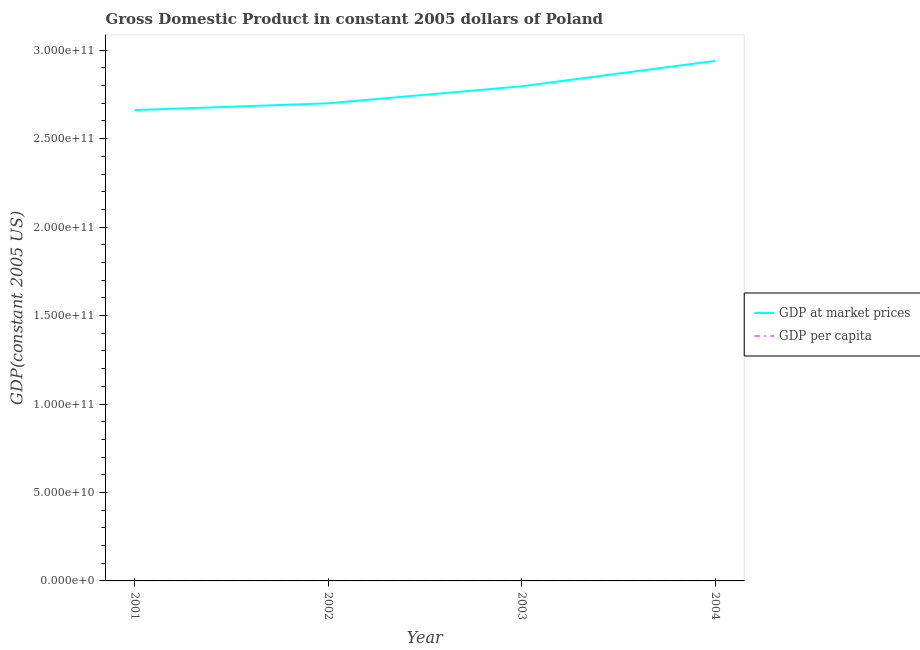Is the number of lines equal to the number of legend labels?
Your answer should be very brief. Yes. What is the gdp at market prices in 2002?
Your answer should be very brief. 2.70e+11. Across all years, what is the maximum gdp at market prices?
Provide a succinct answer. 2.94e+11. Across all years, what is the minimum gdp per capita?
Offer a terse response. 6958.81. In which year was the gdp at market prices maximum?
Your response must be concise. 2004. What is the total gdp at market prices in the graph?
Offer a very short reply. 1.11e+12. What is the difference between the gdp at market prices in 2003 and that in 2004?
Provide a short and direct response. -1.44e+1. What is the difference between the gdp at market prices in 2004 and the gdp per capita in 2002?
Give a very brief answer. 2.94e+11. What is the average gdp per capita per year?
Your answer should be very brief. 7259.97. In the year 2001, what is the difference between the gdp at market prices and gdp per capita?
Your answer should be compact. 2.66e+11. What is the ratio of the gdp per capita in 2001 to that in 2002?
Ensure brevity in your answer.  0.99. Is the gdp per capita in 2001 less than that in 2004?
Your answer should be compact. Yes. What is the difference between the highest and the second highest gdp per capita?
Ensure brevity in your answer.  380.39. What is the difference between the highest and the lowest gdp per capita?
Provide a succinct answer. 740.65. In how many years, is the gdp at market prices greater than the average gdp at market prices taken over all years?
Ensure brevity in your answer.  2. Is the sum of the gdp per capita in 2001 and 2002 greater than the maximum gdp at market prices across all years?
Offer a very short reply. No. Is the gdp per capita strictly less than the gdp at market prices over the years?
Your answer should be very brief. Yes. How many years are there in the graph?
Your response must be concise. 4. Does the graph contain grids?
Your response must be concise. No. Where does the legend appear in the graph?
Your answer should be very brief. Center right. How many legend labels are there?
Give a very brief answer. 2. How are the legend labels stacked?
Make the answer very short. Vertical. What is the title of the graph?
Give a very brief answer. Gross Domestic Product in constant 2005 dollars of Poland. Does "Private creditors" appear as one of the legend labels in the graph?
Your answer should be compact. No. What is the label or title of the Y-axis?
Your answer should be very brief. GDP(constant 2005 US). What is the GDP(constant 2005 US) of GDP at market prices in 2001?
Provide a short and direct response. 2.66e+11. What is the GDP(constant 2005 US) of GDP per capita in 2001?
Provide a short and direct response. 6958.81. What is the GDP(constant 2005 US) of GDP at market prices in 2002?
Ensure brevity in your answer.  2.70e+11. What is the GDP(constant 2005 US) in GDP per capita in 2002?
Give a very brief answer. 7062.53. What is the GDP(constant 2005 US) in GDP at market prices in 2003?
Your response must be concise. 2.80e+11. What is the GDP(constant 2005 US) in GDP per capita in 2003?
Your answer should be very brief. 7319.07. What is the GDP(constant 2005 US) in GDP at market prices in 2004?
Keep it short and to the point. 2.94e+11. What is the GDP(constant 2005 US) in GDP per capita in 2004?
Offer a very short reply. 7699.46. Across all years, what is the maximum GDP(constant 2005 US) of GDP at market prices?
Provide a short and direct response. 2.94e+11. Across all years, what is the maximum GDP(constant 2005 US) of GDP per capita?
Your answer should be compact. 7699.46. Across all years, what is the minimum GDP(constant 2005 US) of GDP at market prices?
Keep it short and to the point. 2.66e+11. Across all years, what is the minimum GDP(constant 2005 US) of GDP per capita?
Your response must be concise. 6958.81. What is the total GDP(constant 2005 US) in GDP at market prices in the graph?
Offer a terse response. 1.11e+12. What is the total GDP(constant 2005 US) of GDP per capita in the graph?
Your answer should be very brief. 2.90e+04. What is the difference between the GDP(constant 2005 US) in GDP at market prices in 2001 and that in 2002?
Your response must be concise. -3.84e+09. What is the difference between the GDP(constant 2005 US) of GDP per capita in 2001 and that in 2002?
Provide a short and direct response. -103.72. What is the difference between the GDP(constant 2005 US) of GDP at market prices in 2001 and that in 2003?
Give a very brief answer. -1.35e+1. What is the difference between the GDP(constant 2005 US) of GDP per capita in 2001 and that in 2003?
Your answer should be very brief. -360.26. What is the difference between the GDP(constant 2005 US) of GDP at market prices in 2001 and that in 2004?
Offer a terse response. -2.78e+1. What is the difference between the GDP(constant 2005 US) in GDP per capita in 2001 and that in 2004?
Your answer should be compact. -740.65. What is the difference between the GDP(constant 2005 US) in GDP at market prices in 2002 and that in 2003?
Provide a succinct answer. -9.62e+09. What is the difference between the GDP(constant 2005 US) in GDP per capita in 2002 and that in 2003?
Your answer should be very brief. -256.54. What is the difference between the GDP(constant 2005 US) of GDP at market prices in 2002 and that in 2004?
Give a very brief answer. -2.40e+1. What is the difference between the GDP(constant 2005 US) in GDP per capita in 2002 and that in 2004?
Keep it short and to the point. -636.93. What is the difference between the GDP(constant 2005 US) of GDP at market prices in 2003 and that in 2004?
Offer a very short reply. -1.44e+1. What is the difference between the GDP(constant 2005 US) in GDP per capita in 2003 and that in 2004?
Offer a very short reply. -380.39. What is the difference between the GDP(constant 2005 US) of GDP at market prices in 2001 and the GDP(constant 2005 US) of GDP per capita in 2002?
Offer a terse response. 2.66e+11. What is the difference between the GDP(constant 2005 US) in GDP at market prices in 2001 and the GDP(constant 2005 US) in GDP per capita in 2003?
Provide a succinct answer. 2.66e+11. What is the difference between the GDP(constant 2005 US) of GDP at market prices in 2001 and the GDP(constant 2005 US) of GDP per capita in 2004?
Your response must be concise. 2.66e+11. What is the difference between the GDP(constant 2005 US) of GDP at market prices in 2002 and the GDP(constant 2005 US) of GDP per capita in 2003?
Offer a terse response. 2.70e+11. What is the difference between the GDP(constant 2005 US) in GDP at market prices in 2002 and the GDP(constant 2005 US) in GDP per capita in 2004?
Provide a succinct answer. 2.70e+11. What is the difference between the GDP(constant 2005 US) in GDP at market prices in 2003 and the GDP(constant 2005 US) in GDP per capita in 2004?
Your response must be concise. 2.80e+11. What is the average GDP(constant 2005 US) of GDP at market prices per year?
Make the answer very short. 2.77e+11. What is the average GDP(constant 2005 US) of GDP per capita per year?
Give a very brief answer. 7259.97. In the year 2001, what is the difference between the GDP(constant 2005 US) of GDP at market prices and GDP(constant 2005 US) of GDP per capita?
Keep it short and to the point. 2.66e+11. In the year 2002, what is the difference between the GDP(constant 2005 US) of GDP at market prices and GDP(constant 2005 US) of GDP per capita?
Ensure brevity in your answer.  2.70e+11. In the year 2003, what is the difference between the GDP(constant 2005 US) of GDP at market prices and GDP(constant 2005 US) of GDP per capita?
Give a very brief answer. 2.80e+11. In the year 2004, what is the difference between the GDP(constant 2005 US) of GDP at market prices and GDP(constant 2005 US) of GDP per capita?
Make the answer very short. 2.94e+11. What is the ratio of the GDP(constant 2005 US) of GDP at market prices in 2001 to that in 2002?
Offer a terse response. 0.99. What is the ratio of the GDP(constant 2005 US) of GDP per capita in 2001 to that in 2002?
Your answer should be very brief. 0.99. What is the ratio of the GDP(constant 2005 US) in GDP at market prices in 2001 to that in 2003?
Give a very brief answer. 0.95. What is the ratio of the GDP(constant 2005 US) in GDP per capita in 2001 to that in 2003?
Ensure brevity in your answer.  0.95. What is the ratio of the GDP(constant 2005 US) of GDP at market prices in 2001 to that in 2004?
Provide a short and direct response. 0.91. What is the ratio of the GDP(constant 2005 US) of GDP per capita in 2001 to that in 2004?
Provide a short and direct response. 0.9. What is the ratio of the GDP(constant 2005 US) in GDP at market prices in 2002 to that in 2003?
Keep it short and to the point. 0.97. What is the ratio of the GDP(constant 2005 US) in GDP per capita in 2002 to that in 2003?
Make the answer very short. 0.96. What is the ratio of the GDP(constant 2005 US) in GDP at market prices in 2002 to that in 2004?
Offer a very short reply. 0.92. What is the ratio of the GDP(constant 2005 US) in GDP per capita in 2002 to that in 2004?
Your answer should be very brief. 0.92. What is the ratio of the GDP(constant 2005 US) of GDP at market prices in 2003 to that in 2004?
Offer a very short reply. 0.95. What is the ratio of the GDP(constant 2005 US) of GDP per capita in 2003 to that in 2004?
Keep it short and to the point. 0.95. What is the difference between the highest and the second highest GDP(constant 2005 US) in GDP at market prices?
Your response must be concise. 1.44e+1. What is the difference between the highest and the second highest GDP(constant 2005 US) in GDP per capita?
Your response must be concise. 380.39. What is the difference between the highest and the lowest GDP(constant 2005 US) in GDP at market prices?
Provide a short and direct response. 2.78e+1. What is the difference between the highest and the lowest GDP(constant 2005 US) of GDP per capita?
Provide a succinct answer. 740.65. 